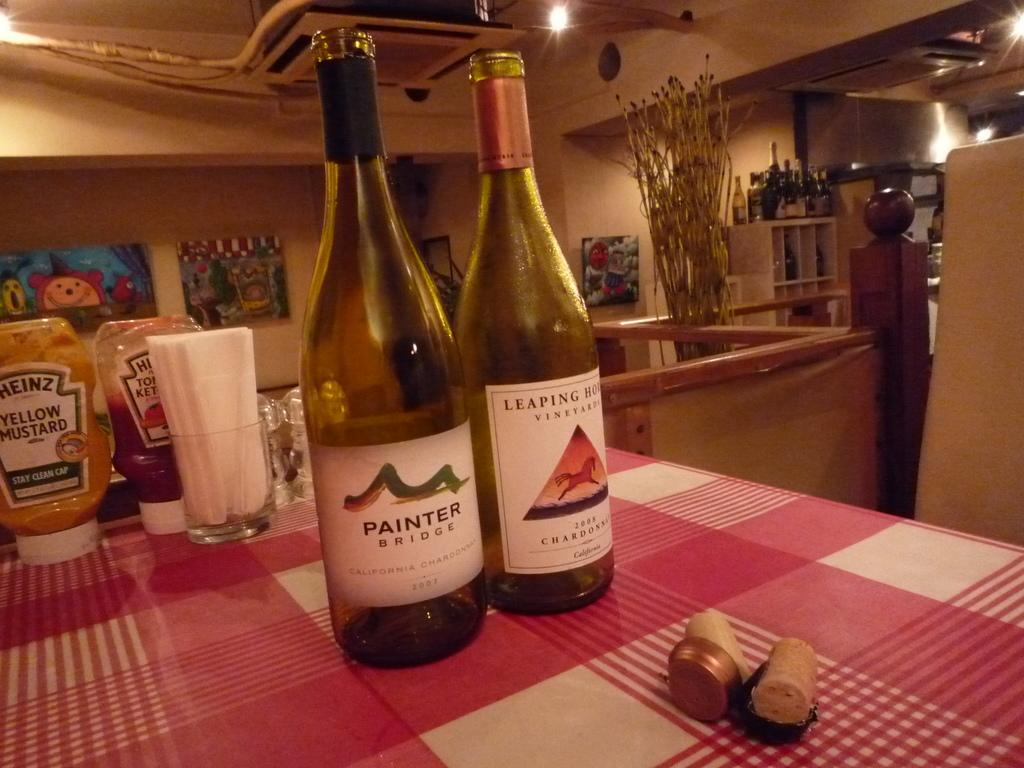<image>
Write a terse but informative summary of the picture. the word Painter that is on a wine bottle 